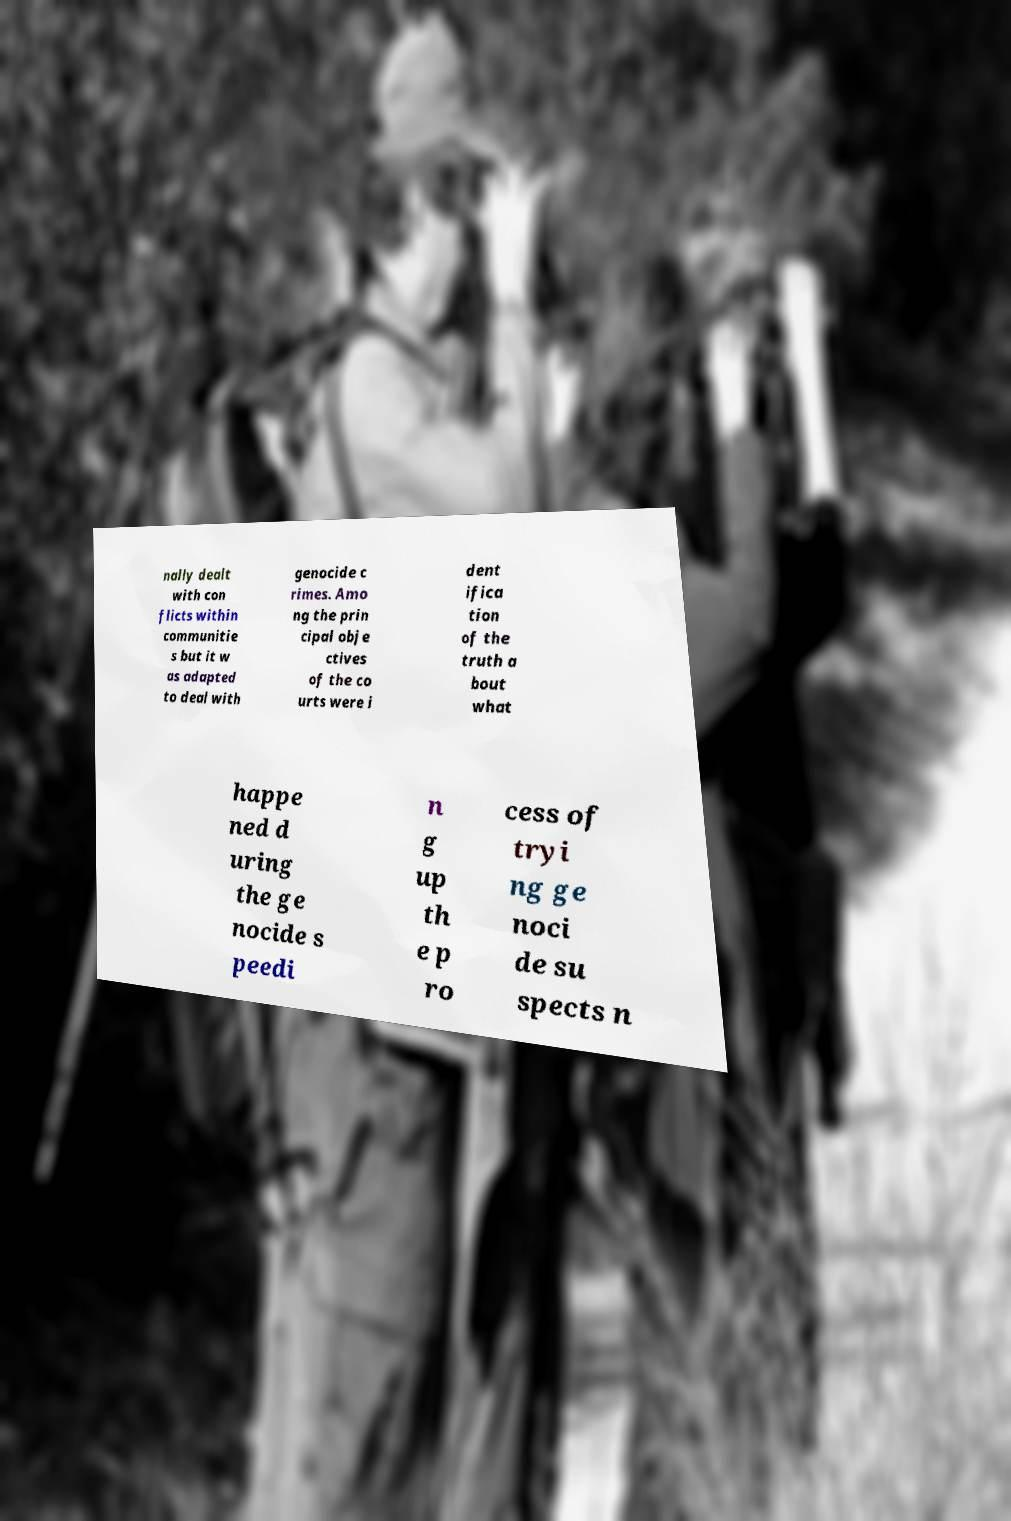Please identify and transcribe the text found in this image. nally dealt with con flicts within communitie s but it w as adapted to deal with genocide c rimes. Amo ng the prin cipal obje ctives of the co urts were i dent ifica tion of the truth a bout what happe ned d uring the ge nocide s peedi n g up th e p ro cess of tryi ng ge noci de su spects n 